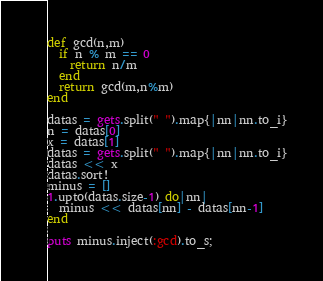<code> <loc_0><loc_0><loc_500><loc_500><_Ruby_>def gcd(n,m)
  if n % m == 0
    return n/m
  end
  return gcd(m,n%m)
end

datas = gets.split(" ").map{|nn|nn.to_i}
n = datas[0]
x = datas[1]
datas = gets.split(" ").map{|nn|nn.to_i}
datas << x
datas.sort!
minus = []
1.upto(datas.size-1) do|nn|
  minus << datas[nn] - datas[nn-1]
end

puts minus.inject(:gcd).to_s;</code> 